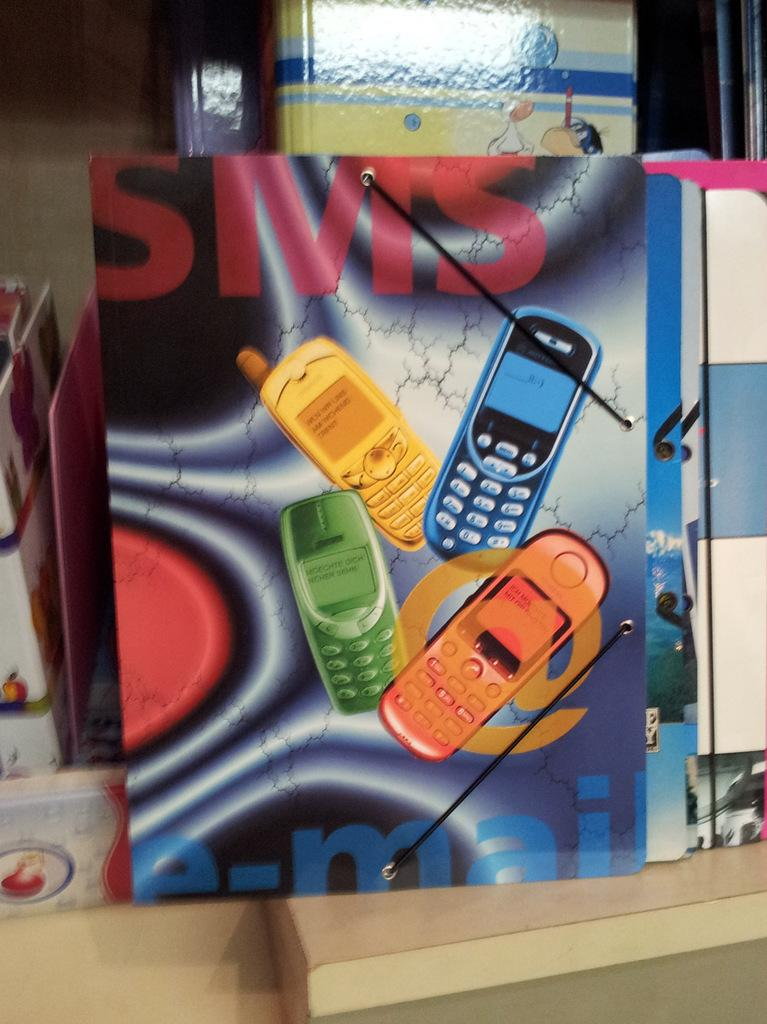What type of objects can be seen in the image? There are books and a wooden object in the image. Can you describe the wooden object in the image? Unfortunately, the facts provided do not give enough information to describe the wooden object in detail. How many books are visible in the image? The facts provided do not specify the number of books in the image. What type of breakfast is being served on the wing in the image? There is no wing or breakfast present in the image; it only contains books and a wooden object. 